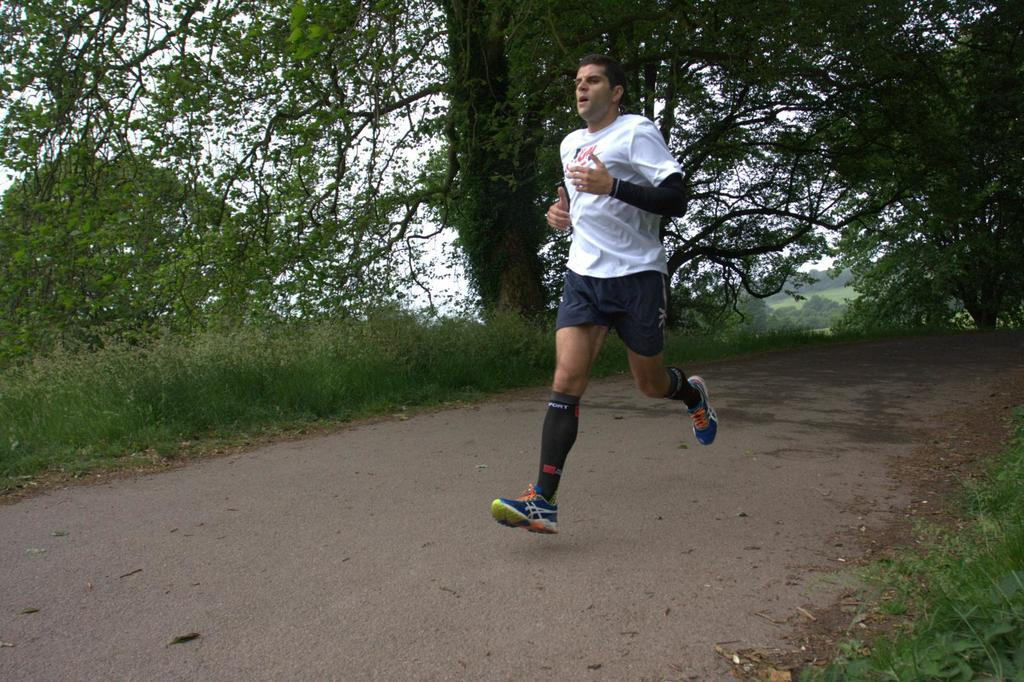Who is the main subject in the front of the image? There is a man standing in the front of the image. What type of vegetation can be seen on both sides of the image? There is grass on the right side and the left side of the image. What can be seen in the background of the image? There are trees and the sky visible in the background of the image. What year is depicted in the image? The image does not depict a specific year; it is a photograph of a man, grass, trees, and the sky. How does the sun appear in the image? The sun is not visible in the image; only the sky is visible in the background. 